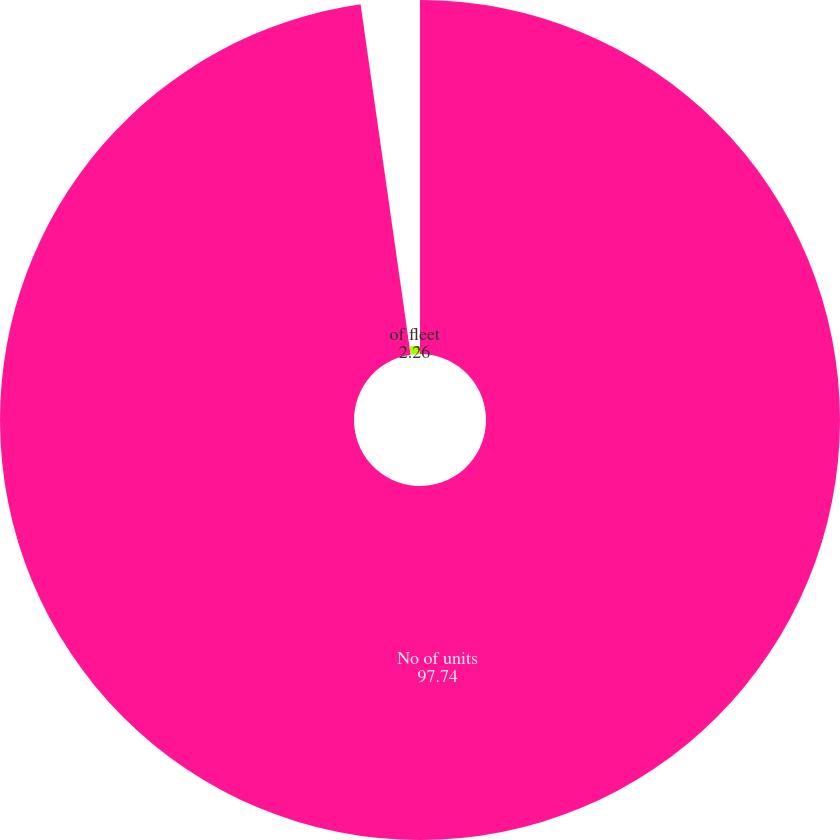Convert chart to OTSL. <chart><loc_0><loc_0><loc_500><loc_500><pie_chart><fcel>No of units<fcel>of fleet<nl><fcel>97.74%<fcel>2.26%<nl></chart> 